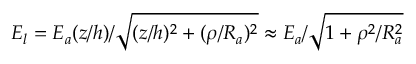<formula> <loc_0><loc_0><loc_500><loc_500>E _ { l } = E _ { a } ( z / h ) / \sqrt { ( z / h ) ^ { 2 } + ( \rho / R _ { a } ) ^ { 2 } } \approx E _ { a } / \sqrt { 1 + \rho ^ { 2 } / R _ { a } ^ { 2 } }</formula> 